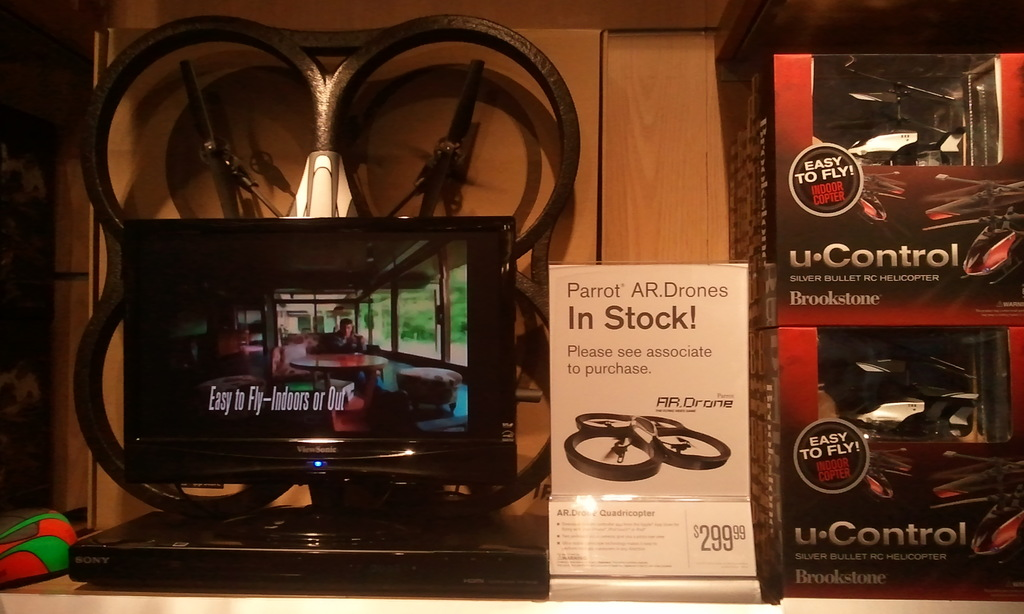What is displayed on the screen of the DVD player in the image? The DVD player displays a promotional video showing a tranquil indoor environment, with a message highlighting the ease of flying the drones, either indoors or outdoors. 